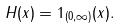<formula> <loc_0><loc_0><loc_500><loc_500>H ( x ) = 1 _ { ( 0 , \infty ) } ( x ) .</formula> 